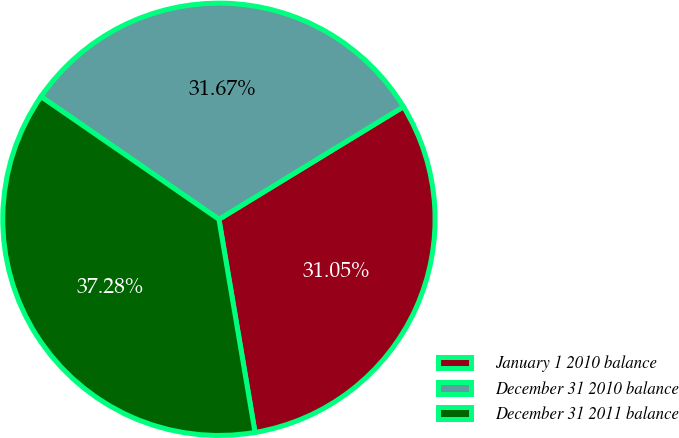Convert chart. <chart><loc_0><loc_0><loc_500><loc_500><pie_chart><fcel>January 1 2010 balance<fcel>December 31 2010 balance<fcel>December 31 2011 balance<nl><fcel>31.05%<fcel>31.67%<fcel>37.28%<nl></chart> 